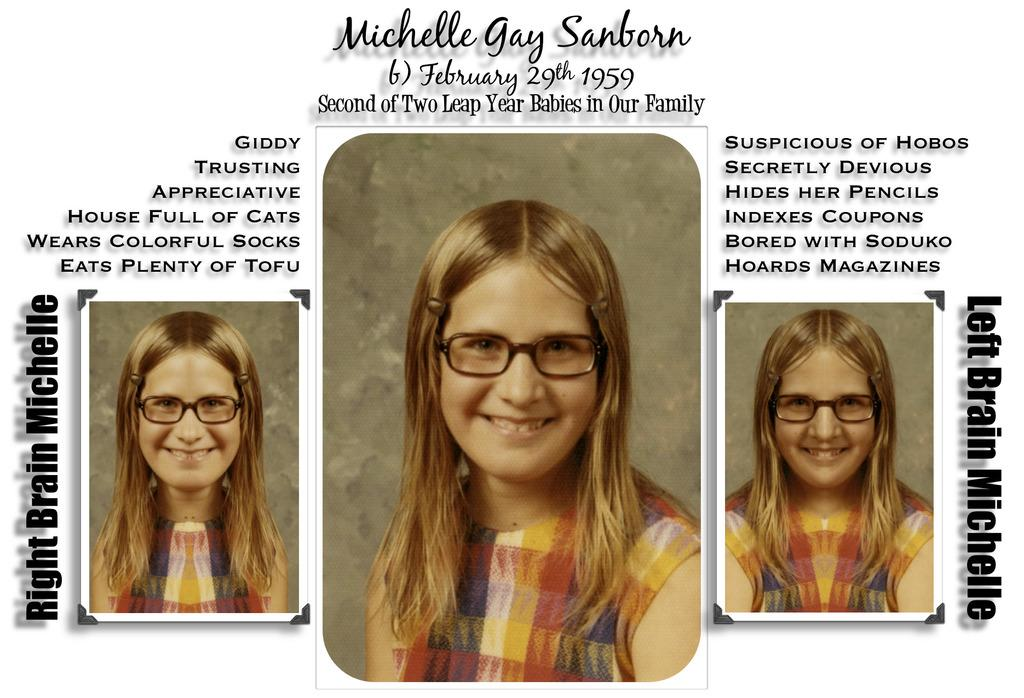What is depicted in the images in the picture? There are pictures of a woman in the image. What else can be seen on the image besides the pictures of the woman? There are texts written on the image. What is the level of noise during the meeting in the image? There is no meeting depicted in the image, so it is not possible to determine the level of noise. 